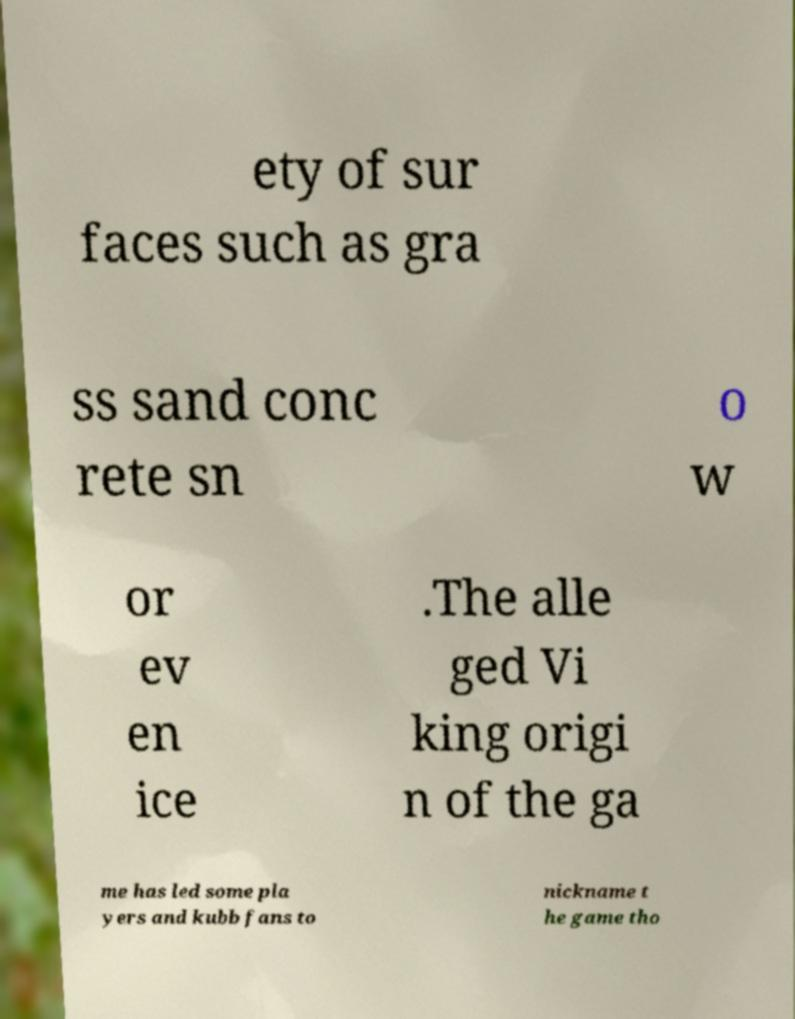Please identify and transcribe the text found in this image. ety of sur faces such as gra ss sand conc rete sn o w or ev en ice .The alle ged Vi king origi n of the ga me has led some pla yers and kubb fans to nickname t he game tho 